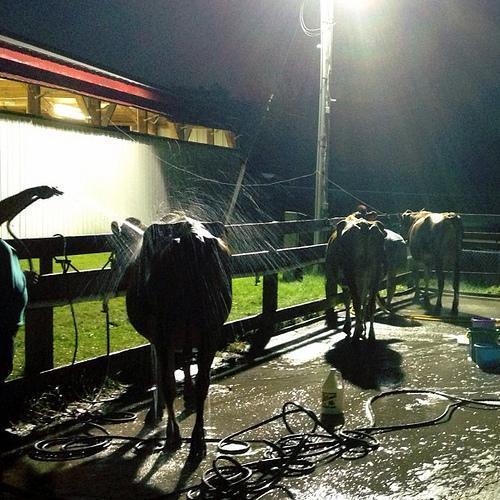How many cows are in the photo?
Give a very brief answer. 4. 